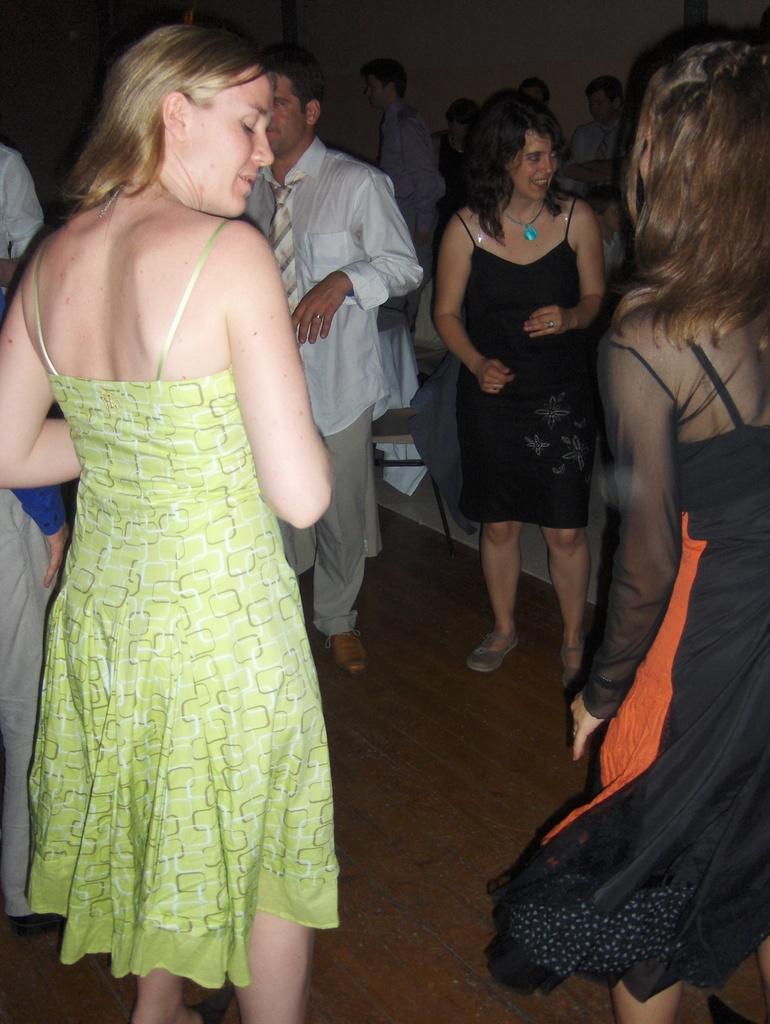Please provide a concise description of this image. In this image we can see a group of people standing on the floor. On the backside we can see a chair and a wall. 